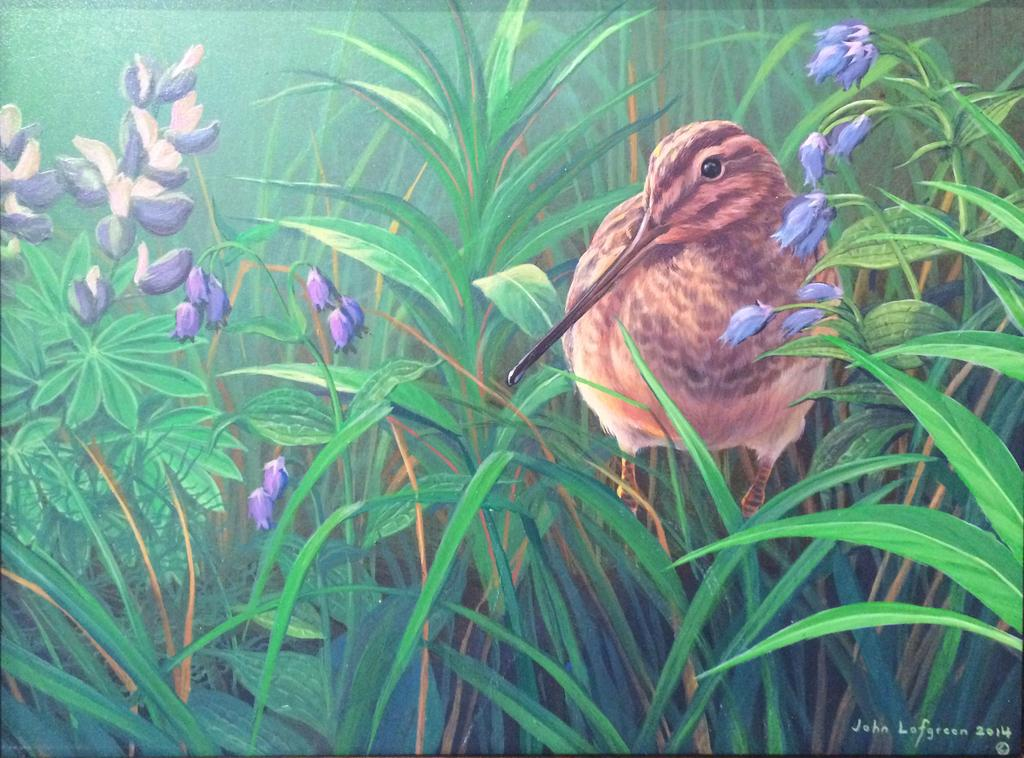What type of artwork is depicted in the image? The image appears to be a painting. What natural elements can be seen in the painting? There are plants and flowers in the image. Are there any animals present in the painting? Yes, there is a bird in the image. What type of cream is being used by the bird in the image? There is no cream present in the image, and the bird is not using any cream. How many feet does the bird have in the image? The image does not show the bird's feet, so it cannot be determined from the image. 